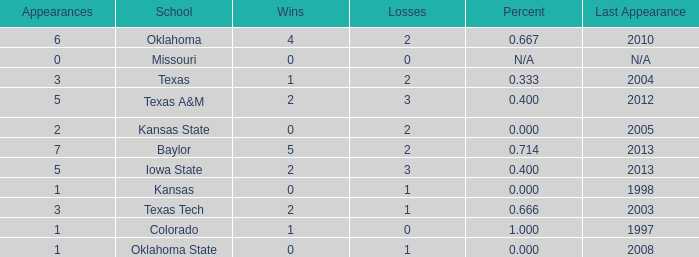How many wins did Baylor have?  1.0. 